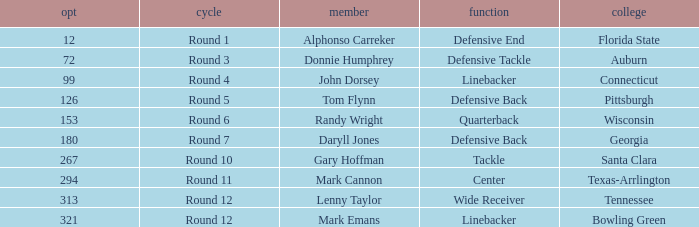What is Mark Cannon's College? Texas-Arrlington. 